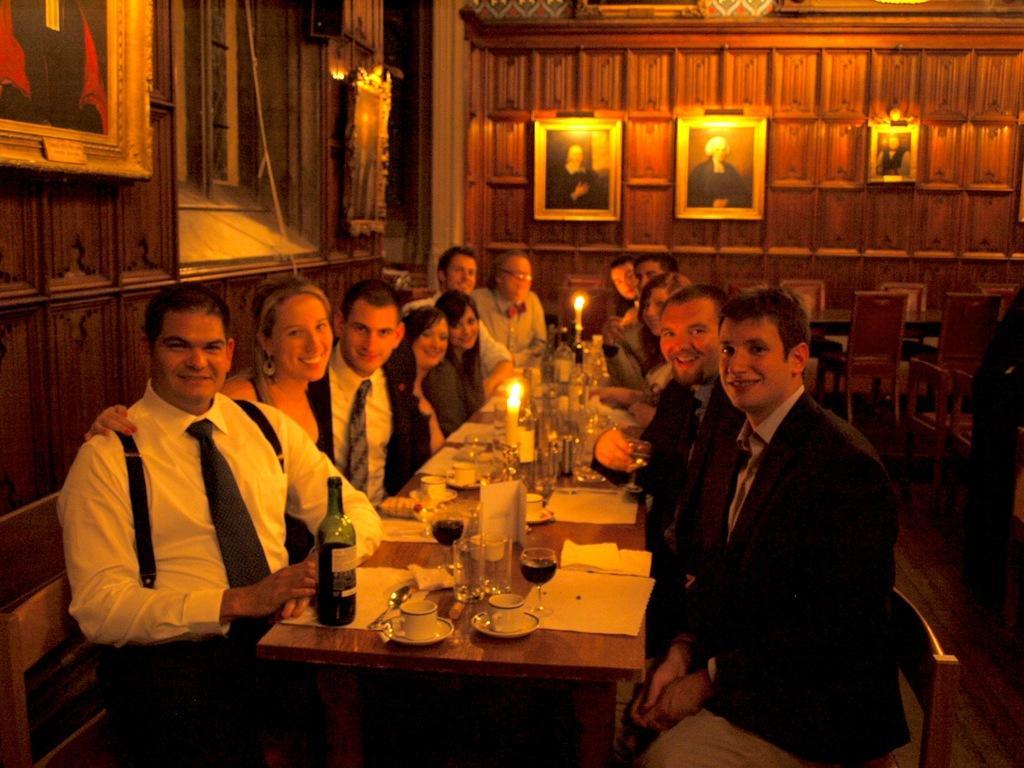How would you summarize this image in a sentence or two? Here we can see some persons are sitting on the chairs. This is table. On the table there are bottles, cups, glasses, and candles. There are chairs and this is floor. On the background there is a wall and these are the frames. 